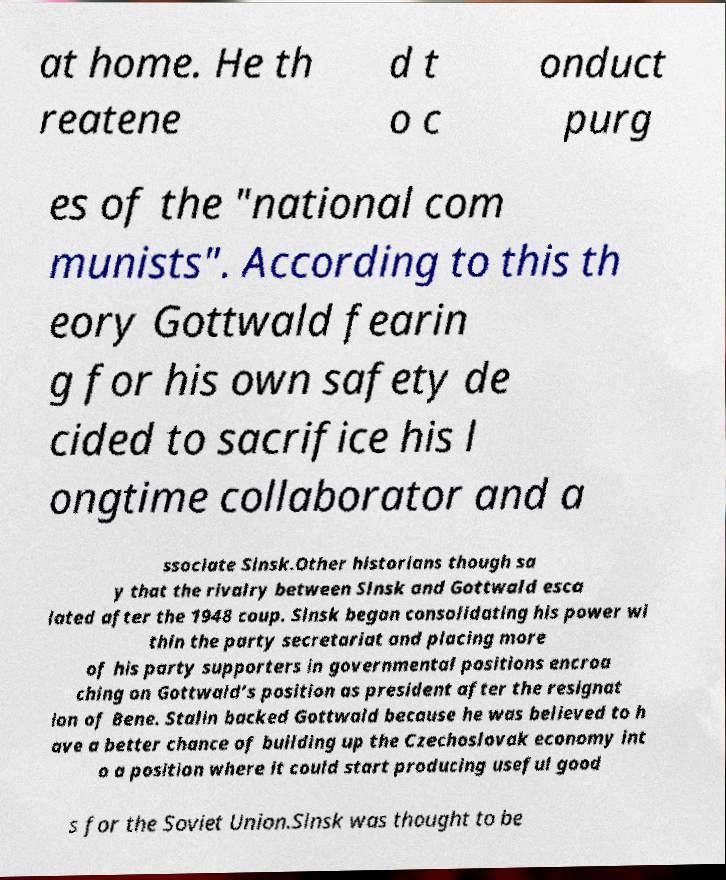Please read and relay the text visible in this image. What does it say? at home. He th reatene d t o c onduct purg es of the "national com munists". According to this th eory Gottwald fearin g for his own safety de cided to sacrifice his l ongtime collaborator and a ssociate Slnsk.Other historians though sa y that the rivalry between Slnsk and Gottwald esca lated after the 1948 coup. Slnsk began consolidating his power wi thin the party secretariat and placing more of his party supporters in governmental positions encroa ching on Gottwald’s position as president after the resignat ion of Bene. Stalin backed Gottwald because he was believed to h ave a better chance of building up the Czechoslovak economy int o a position where it could start producing useful good s for the Soviet Union.Slnsk was thought to be 